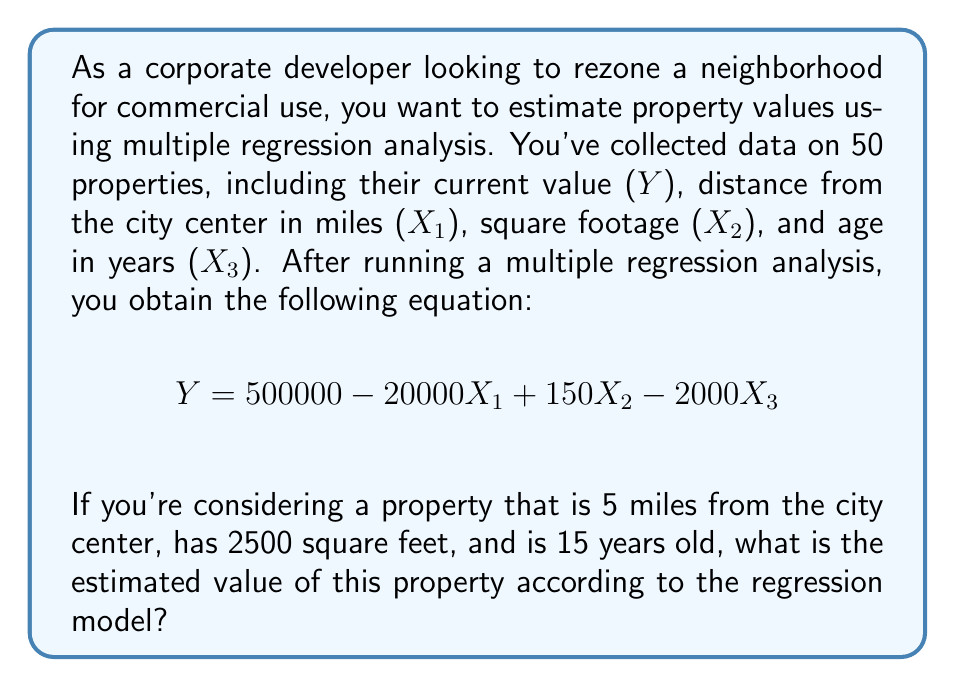Teach me how to tackle this problem. To solve this problem, we'll use the multiple regression equation provided and plug in the values for our specific property:

1. Given equation:
   $$ Y = 500000 - 20000X_1 + 150X_2 - 2000X_3 $$

2. Property characteristics:
   - Distance from city center (X₁) = 5 miles
   - Square footage (X₂) = 2500 sq ft
   - Age (X₃) = 15 years

3. Substitute the values into the equation:
   $$ Y = 500000 - 20000(5) + 150(2500) - 2000(15) $$

4. Calculate each term:
   $$ Y = 500000 - 100000 + 375000 - 30000 $$

5. Sum up the terms:
   $$ Y = 745000 $$

Therefore, the estimated value of the property according to the regression model is $745,000.

This multiple regression analysis allows us to consider multiple factors simultaneously when estimating property values, which is crucial for making informed decisions about rezoning and potential commercial development.
Answer: $745,000 